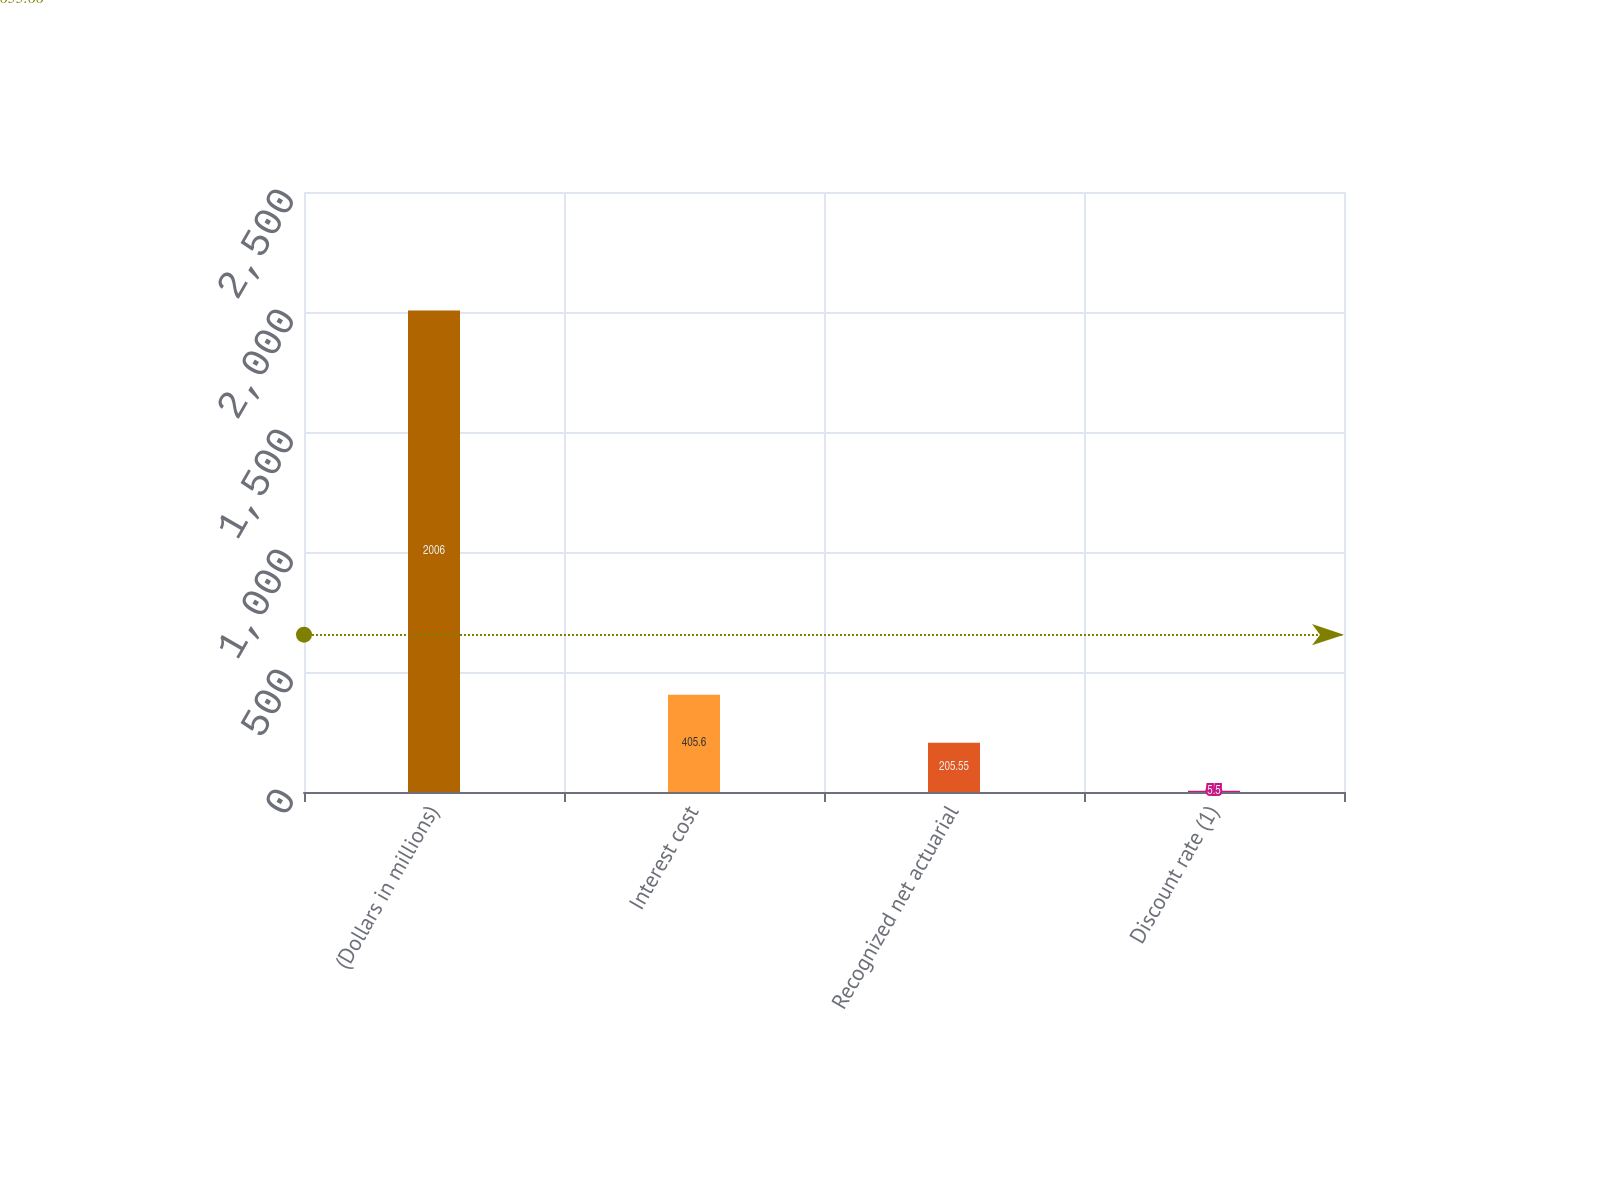Convert chart. <chart><loc_0><loc_0><loc_500><loc_500><bar_chart><fcel>(Dollars in millions)<fcel>Interest cost<fcel>Recognized net actuarial<fcel>Discount rate (1)<nl><fcel>2006<fcel>405.6<fcel>205.55<fcel>5.5<nl></chart> 